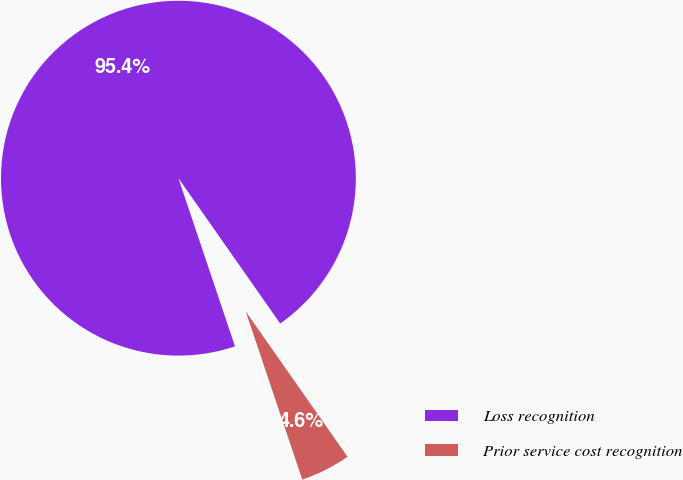<chart> <loc_0><loc_0><loc_500><loc_500><pie_chart><fcel>Loss recognition<fcel>Prior service cost recognition<nl><fcel>95.44%<fcel>4.56%<nl></chart> 